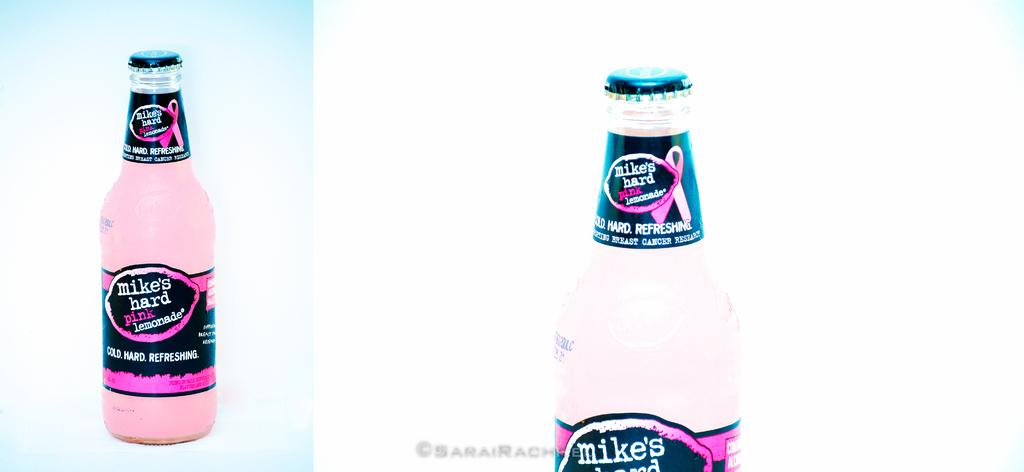<image>
Summarize the visual content of the image. A bottle with pink liquid is labeled Mike's hard pink Lemonade. 